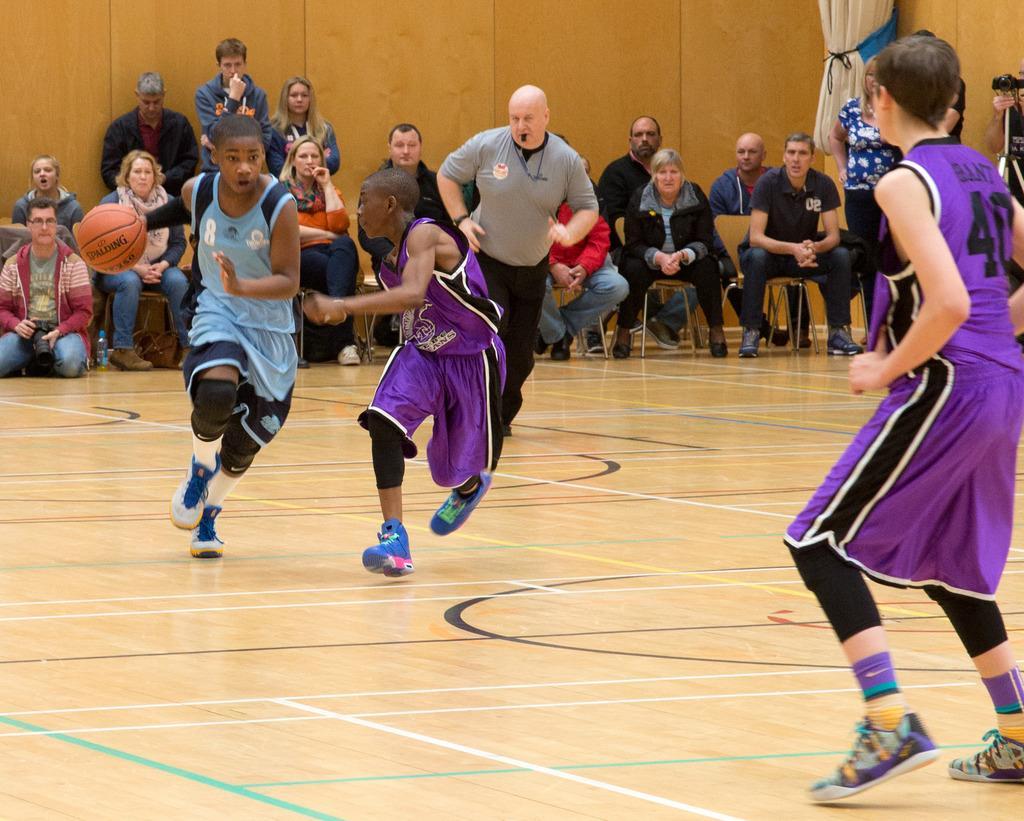Please provide a concise description of this image. In this picture I can observe three boys playing basketball in the basketball court. In the background I can observe some people sitting on the chairs and I can observe wall behind them. 